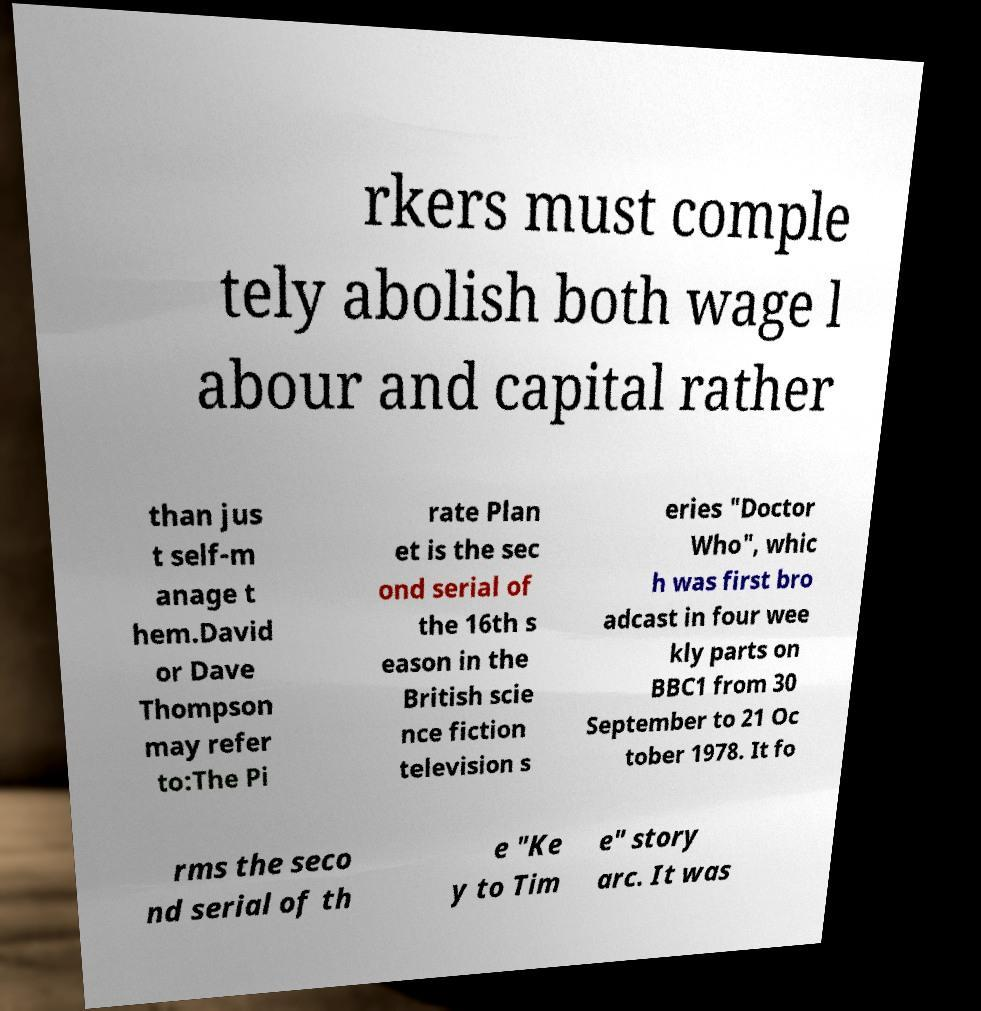Could you extract and type out the text from this image? rkers must comple tely abolish both wage l abour and capital rather than jus t self-m anage t hem.David or Dave Thompson may refer to:The Pi rate Plan et is the sec ond serial of the 16th s eason in the British scie nce fiction television s eries "Doctor Who", whic h was first bro adcast in four wee kly parts on BBC1 from 30 September to 21 Oc tober 1978. It fo rms the seco nd serial of th e "Ke y to Tim e" story arc. It was 